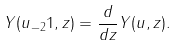Convert formula to latex. <formula><loc_0><loc_0><loc_500><loc_500>Y ( u _ { - 2 } 1 , z ) = \frac { d } { d z } Y ( u , z ) .</formula> 